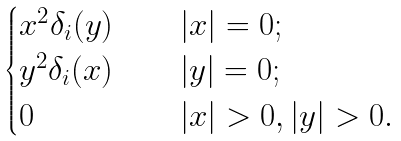<formula> <loc_0><loc_0><loc_500><loc_500>\begin{cases} x ^ { 2 } \delta _ { i } ( y ) & \quad | x | = 0 ; \\ y ^ { 2 } \delta _ { i } ( x ) & \quad | y | = 0 ; \\ 0 & \quad | x | > 0 , | y | > 0 . \end{cases}</formula> 